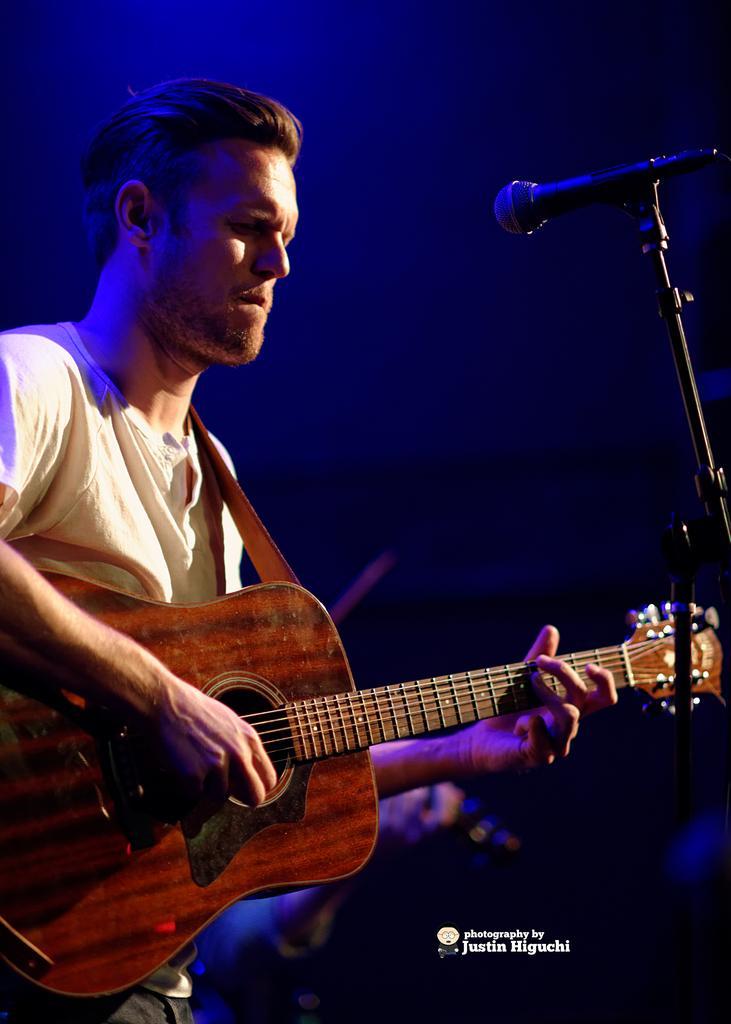Please provide a concise description of this image. there is a person playing guitar. in front of him there is a microphone and its stand 